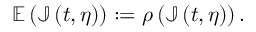Convert formula to latex. <formula><loc_0><loc_0><loc_500><loc_500>\mathbb { E } \left ( \mathbb { J } \left ( t , \eta \right ) \right ) \colon = \rho \left ( \mathbb { J } \left ( t , \eta \right ) \right ) .</formula> 